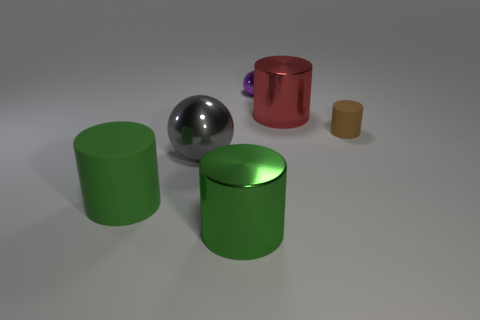Is there anything else of the same color as the tiny matte object?
Make the answer very short. No. What is the shape of the object that is both to the left of the purple shiny object and to the right of the gray metal thing?
Make the answer very short. Cylinder. There is a metal cylinder behind the tiny matte thing; what is its size?
Offer a terse response. Large. There is a cylinder that is on the left side of the gray sphere left of the tiny rubber thing; what number of big green shiny objects are on the left side of it?
Ensure brevity in your answer.  0. Are there any big green things in front of the large matte cylinder?
Offer a terse response. Yes. How many other objects are there of the same size as the red cylinder?
Provide a succinct answer. 3. The big thing that is to the right of the gray thing and left of the tiny ball is made of what material?
Give a very brief answer. Metal. There is a large metal object that is right of the small purple metallic thing; is its shape the same as the large shiny object in front of the big sphere?
Your answer should be compact. Yes. There is a shiny thing in front of the large green cylinder that is to the left of the gray object that is to the left of the big green shiny thing; what shape is it?
Give a very brief answer. Cylinder. What number of other things are the same shape as the green metallic object?
Your answer should be very brief. 3. 